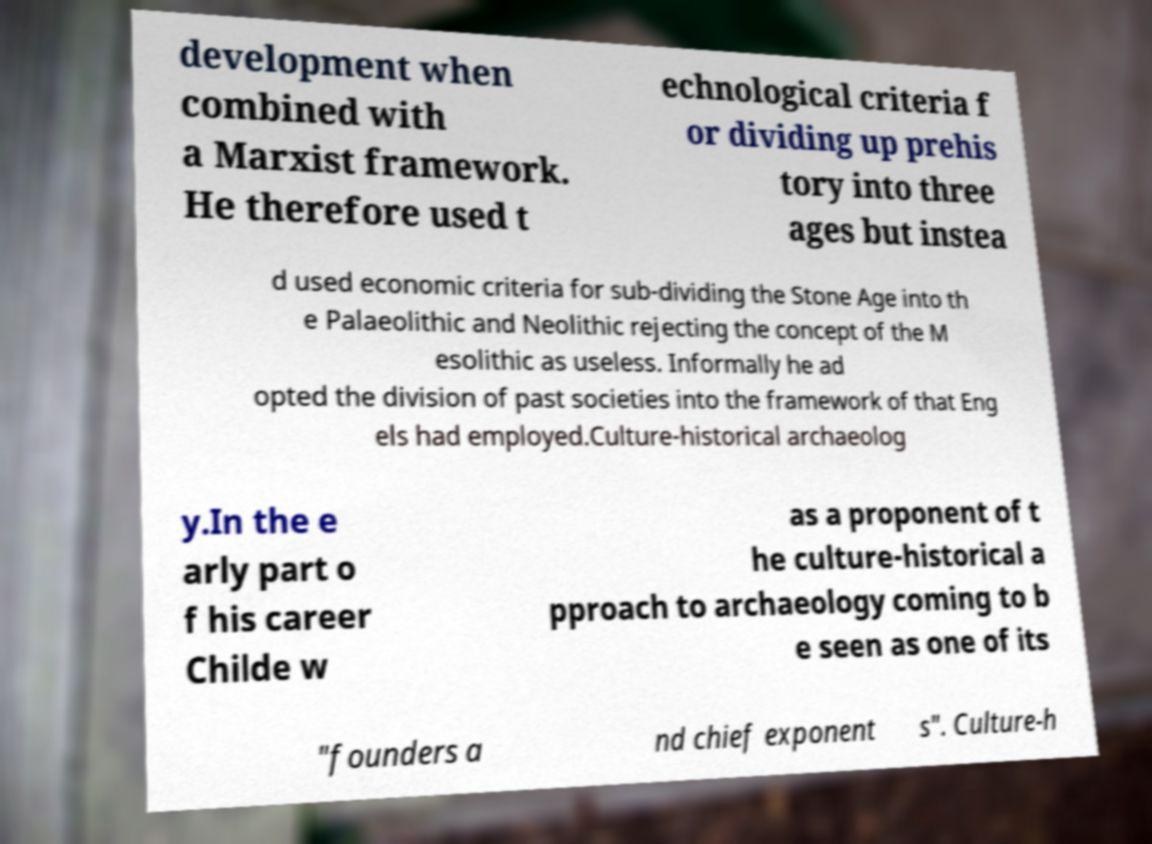I need the written content from this picture converted into text. Can you do that? development when combined with a Marxist framework. He therefore used t echnological criteria f or dividing up prehis tory into three ages but instea d used economic criteria for sub-dividing the Stone Age into th e Palaeolithic and Neolithic rejecting the concept of the M esolithic as useless. Informally he ad opted the division of past societies into the framework of that Eng els had employed.Culture-historical archaeolog y.In the e arly part o f his career Childe w as a proponent of t he culture-historical a pproach to archaeology coming to b e seen as one of its "founders a nd chief exponent s". Culture-h 